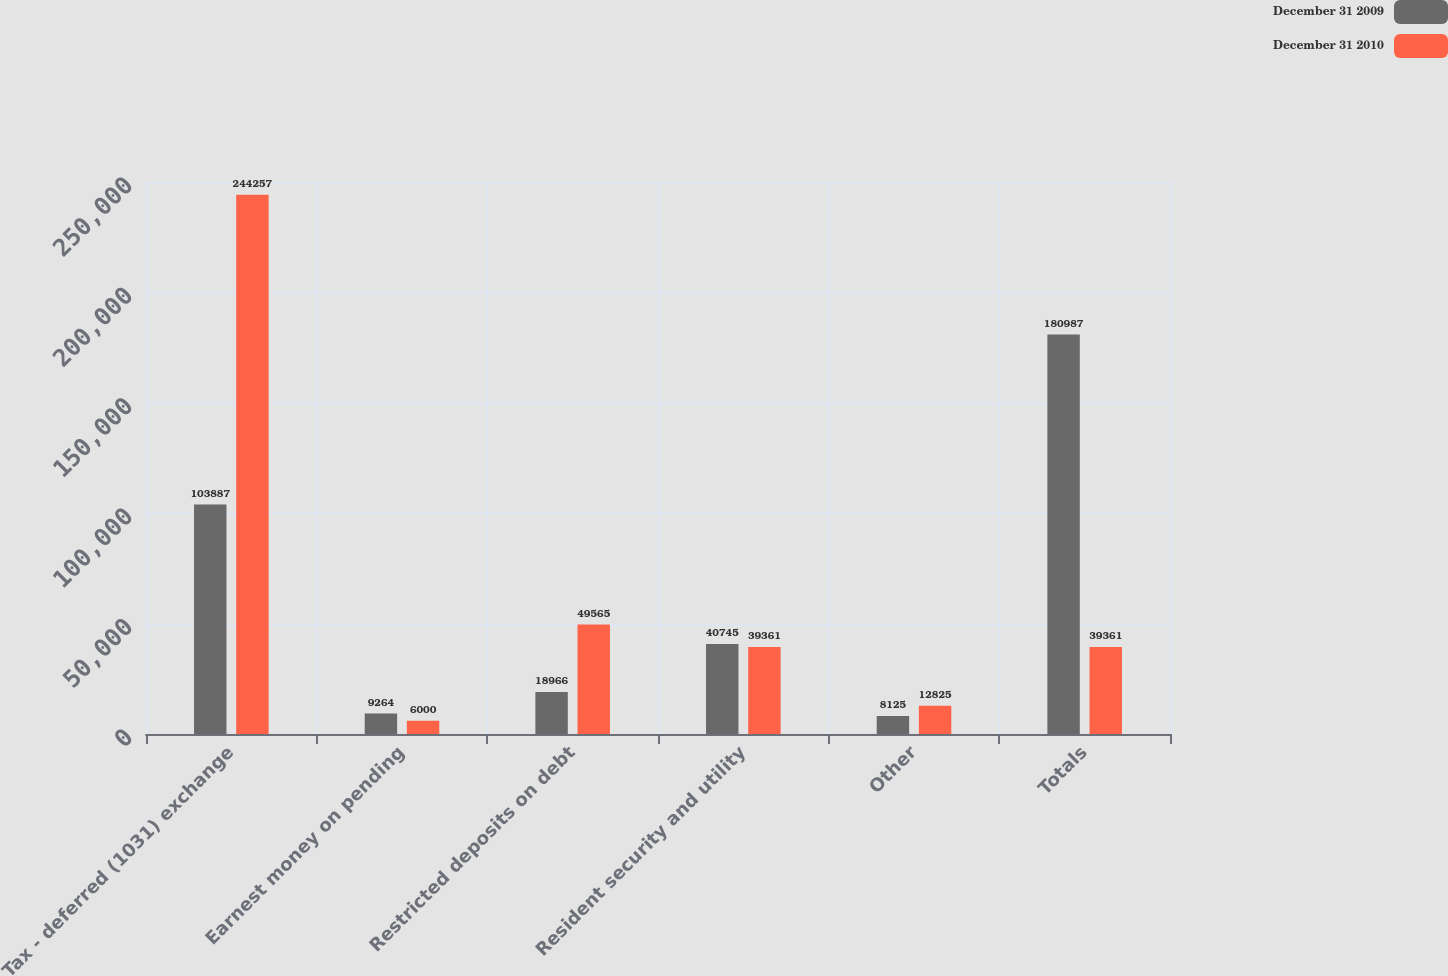Convert chart. <chart><loc_0><loc_0><loc_500><loc_500><stacked_bar_chart><ecel><fcel>Tax - deferred (1031) exchange<fcel>Earnest money on pending<fcel>Restricted deposits on debt<fcel>Resident security and utility<fcel>Other<fcel>Totals<nl><fcel>December 31 2009<fcel>103887<fcel>9264<fcel>18966<fcel>40745<fcel>8125<fcel>180987<nl><fcel>December 31 2010<fcel>244257<fcel>6000<fcel>49565<fcel>39361<fcel>12825<fcel>39361<nl></chart> 